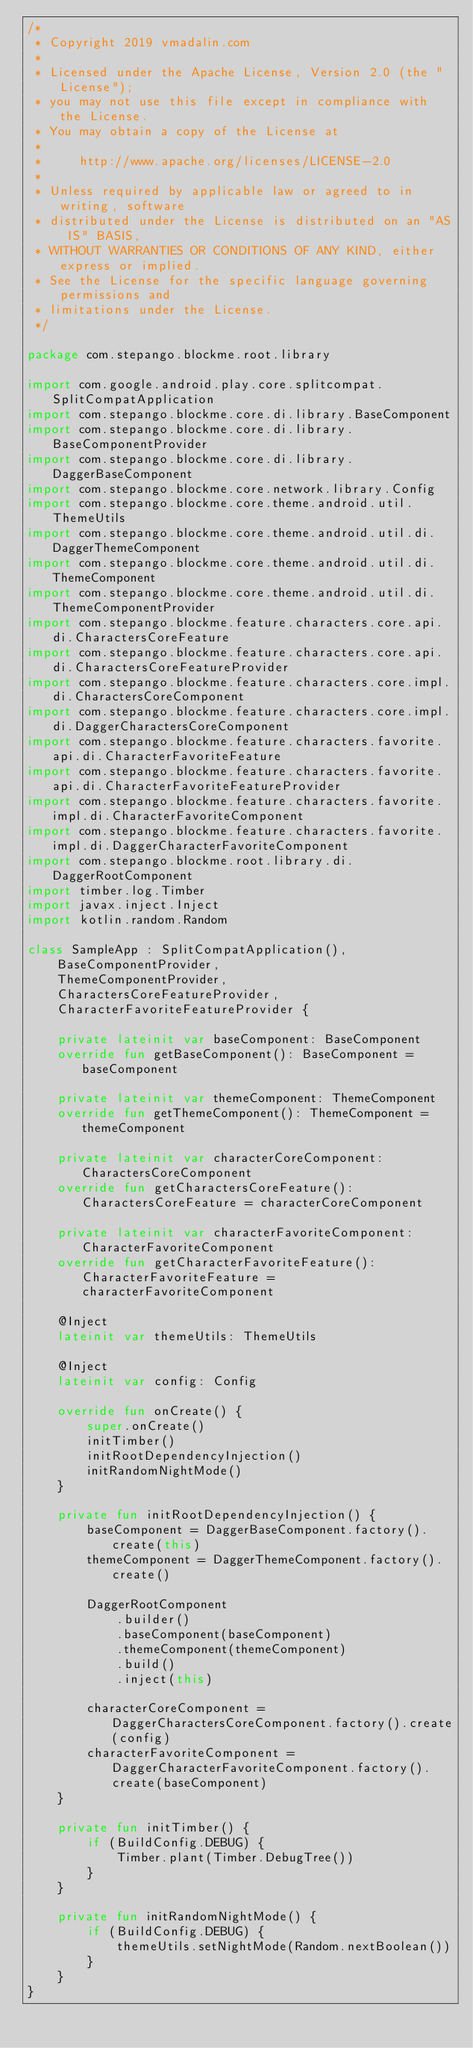Convert code to text. <code><loc_0><loc_0><loc_500><loc_500><_Kotlin_>/*
 * Copyright 2019 vmadalin.com
 *
 * Licensed under the Apache License, Version 2.0 (the "License");
 * you may not use this file except in compliance with the License.
 * You may obtain a copy of the License at
 *
 *     http://www.apache.org/licenses/LICENSE-2.0
 *
 * Unless required by applicable law or agreed to in writing, software
 * distributed under the License is distributed on an "AS IS" BASIS,
 * WITHOUT WARRANTIES OR CONDITIONS OF ANY KIND, either express or implied.
 * See the License for the specific language governing permissions and
 * limitations under the License.
 */

package com.stepango.blockme.root.library

import com.google.android.play.core.splitcompat.SplitCompatApplication
import com.stepango.blockme.core.di.library.BaseComponent
import com.stepango.blockme.core.di.library.BaseComponentProvider
import com.stepango.blockme.core.di.library.DaggerBaseComponent
import com.stepango.blockme.core.network.library.Config
import com.stepango.blockme.core.theme.android.util.ThemeUtils
import com.stepango.blockme.core.theme.android.util.di.DaggerThemeComponent
import com.stepango.blockme.core.theme.android.util.di.ThemeComponent
import com.stepango.blockme.core.theme.android.util.di.ThemeComponentProvider
import com.stepango.blockme.feature.characters.core.api.di.CharactersCoreFeature
import com.stepango.blockme.feature.characters.core.api.di.CharactersCoreFeatureProvider
import com.stepango.blockme.feature.characters.core.impl.di.CharactersCoreComponent
import com.stepango.blockme.feature.characters.core.impl.di.DaggerCharactersCoreComponent
import com.stepango.blockme.feature.characters.favorite.api.di.CharacterFavoriteFeature
import com.stepango.blockme.feature.characters.favorite.api.di.CharacterFavoriteFeatureProvider
import com.stepango.blockme.feature.characters.favorite.impl.di.CharacterFavoriteComponent
import com.stepango.blockme.feature.characters.favorite.impl.di.DaggerCharacterFavoriteComponent
import com.stepango.blockme.root.library.di.DaggerRootComponent
import timber.log.Timber
import javax.inject.Inject
import kotlin.random.Random

class SampleApp : SplitCompatApplication(),
    BaseComponentProvider,
    ThemeComponentProvider,
    CharactersCoreFeatureProvider,
    CharacterFavoriteFeatureProvider {

    private lateinit var baseComponent: BaseComponent
    override fun getBaseComponent(): BaseComponent = baseComponent

    private lateinit var themeComponent: ThemeComponent
    override fun getThemeComponent(): ThemeComponent = themeComponent

    private lateinit var characterCoreComponent: CharactersCoreComponent
    override fun getCharactersCoreFeature(): CharactersCoreFeature = characterCoreComponent

    private lateinit var characterFavoriteComponent: CharacterFavoriteComponent
    override fun getCharacterFavoriteFeature(): CharacterFavoriteFeature = characterFavoriteComponent

    @Inject
    lateinit var themeUtils: ThemeUtils

    @Inject
    lateinit var config: Config

    override fun onCreate() {
        super.onCreate()
        initTimber()
        initRootDependencyInjection()
        initRandomNightMode()
    }

    private fun initRootDependencyInjection() {
        baseComponent = DaggerBaseComponent.factory().create(this)
        themeComponent = DaggerThemeComponent.factory().create()

        DaggerRootComponent
            .builder()
            .baseComponent(baseComponent)
            .themeComponent(themeComponent)
            .build()
            .inject(this)

        characterCoreComponent = DaggerCharactersCoreComponent.factory().create(config)
        characterFavoriteComponent = DaggerCharacterFavoriteComponent.factory().create(baseComponent)
    }

    private fun initTimber() {
        if (BuildConfig.DEBUG) {
            Timber.plant(Timber.DebugTree())
        }
    }

    private fun initRandomNightMode() {
        if (BuildConfig.DEBUG) {
            themeUtils.setNightMode(Random.nextBoolean())
        }
    }
}
</code> 